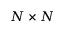Convert formula to latex. <formula><loc_0><loc_0><loc_500><loc_500>N \times N</formula> 